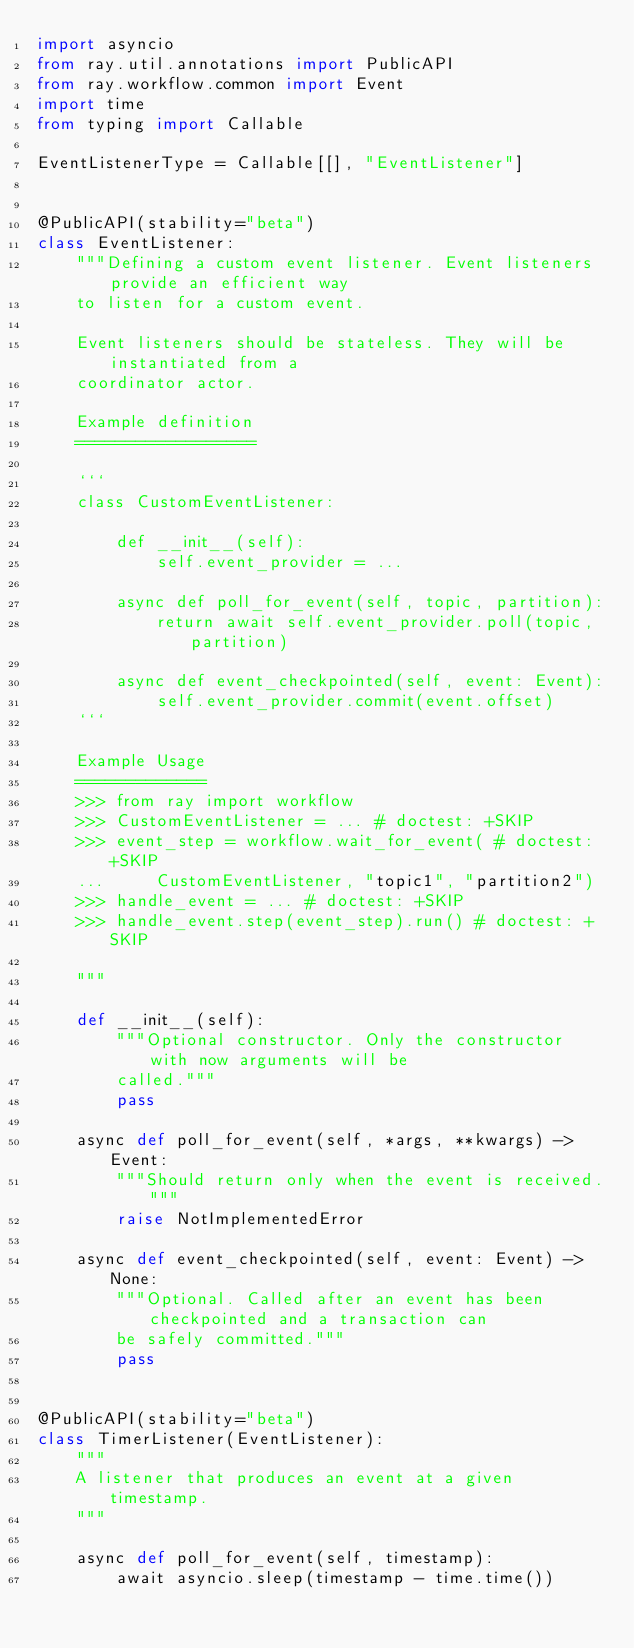Convert code to text. <code><loc_0><loc_0><loc_500><loc_500><_Python_>import asyncio
from ray.util.annotations import PublicAPI
from ray.workflow.common import Event
import time
from typing import Callable

EventListenerType = Callable[[], "EventListener"]


@PublicAPI(stability="beta")
class EventListener:
    """Defining a custom event listener. Event listeners provide an efficient way
    to listen for a custom event.

    Event listeners should be stateless. They will be instantiated from a
    coordinator actor.

    Example definition
    ==================

    ```
    class CustomEventListener:

        def __init__(self):
            self.event_provider = ...

        async def poll_for_event(self, topic, partition):
            return await self.event_provider.poll(topic, partition)

        async def event_checkpointed(self, event: Event):
            self.event_provider.commit(event.offset)
    ```

    Example Usage
    =============
    >>> from ray import workflow
    >>> CustomEventListener = ... # doctest: +SKIP
    >>> event_step = workflow.wait_for_event( # doctest: +SKIP
    ...     CustomEventListener, "topic1", "partition2")
    >>> handle_event = ... # doctest: +SKIP
    >>> handle_event.step(event_step).run() # doctest: +SKIP

    """

    def __init__(self):
        """Optional constructor. Only the constructor with now arguments will be
        called."""
        pass

    async def poll_for_event(self, *args, **kwargs) -> Event:
        """Should return only when the event is received."""
        raise NotImplementedError

    async def event_checkpointed(self, event: Event) -> None:
        """Optional. Called after an event has been checkpointed and a transaction can
        be safely committed."""
        pass


@PublicAPI(stability="beta")
class TimerListener(EventListener):
    """
    A listener that produces an event at a given timestamp.
    """

    async def poll_for_event(self, timestamp):
        await asyncio.sleep(timestamp - time.time())
</code> 